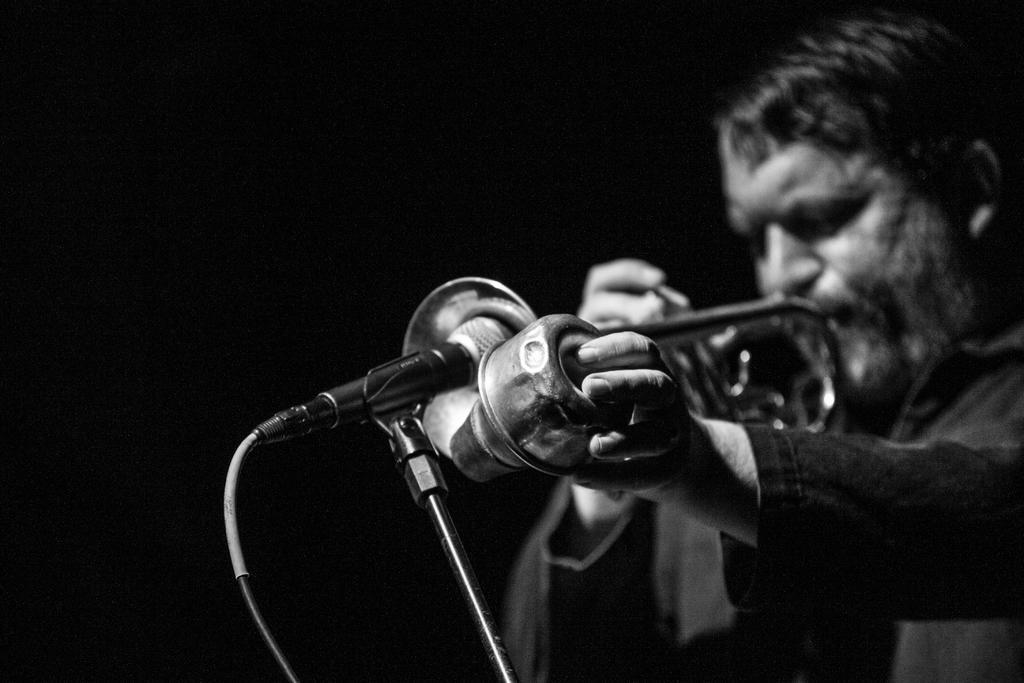Please provide a concise description of this image. In this picture we can see a man is playing trumpet in front of the microphone. 